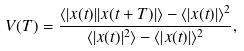<formula> <loc_0><loc_0><loc_500><loc_500>V ( T ) = \frac { \langle | x ( t ) | | x ( t + T ) | \rangle - \langle | x ( t ) | \rangle ^ { 2 } } { \langle | x ( t ) | ^ { 2 } \rangle - \langle | x ( t ) | \rangle ^ { 2 } } ,</formula> 